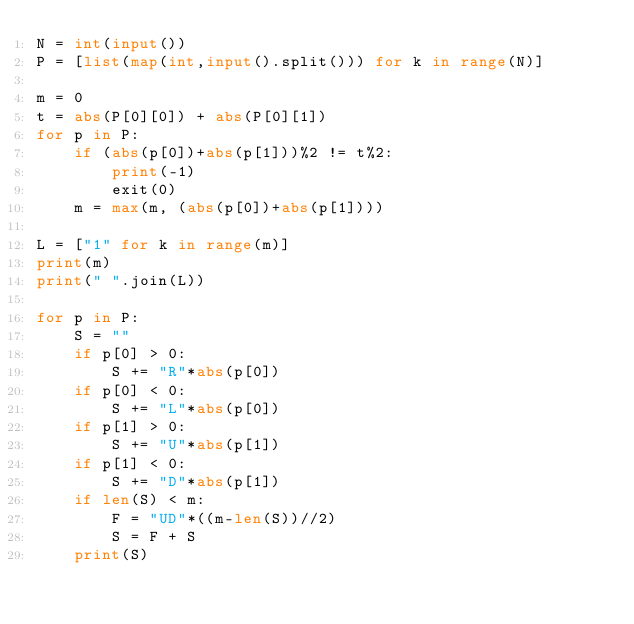<code> <loc_0><loc_0><loc_500><loc_500><_Python_>N = int(input())
P = [list(map(int,input().split())) for k in range(N)]

m = 0
t = abs(P[0][0]) + abs(P[0][1])
for p in P:
    if (abs(p[0])+abs(p[1]))%2 != t%2:
        print(-1)
        exit(0)
    m = max(m, (abs(p[0])+abs(p[1])))

L = ["1" for k in range(m)]
print(m)
print(" ".join(L))

for p in P:
    S = ""
    if p[0] > 0:
        S += "R"*abs(p[0])
    if p[0] < 0:
        S += "L"*abs(p[0])
    if p[1] > 0:
        S += "U"*abs(p[1])
    if p[1] < 0:
        S += "D"*abs(p[1])
    if len(S) < m:
        F = "UD"*((m-len(S))//2)
        S = F + S
    print(S)</code> 